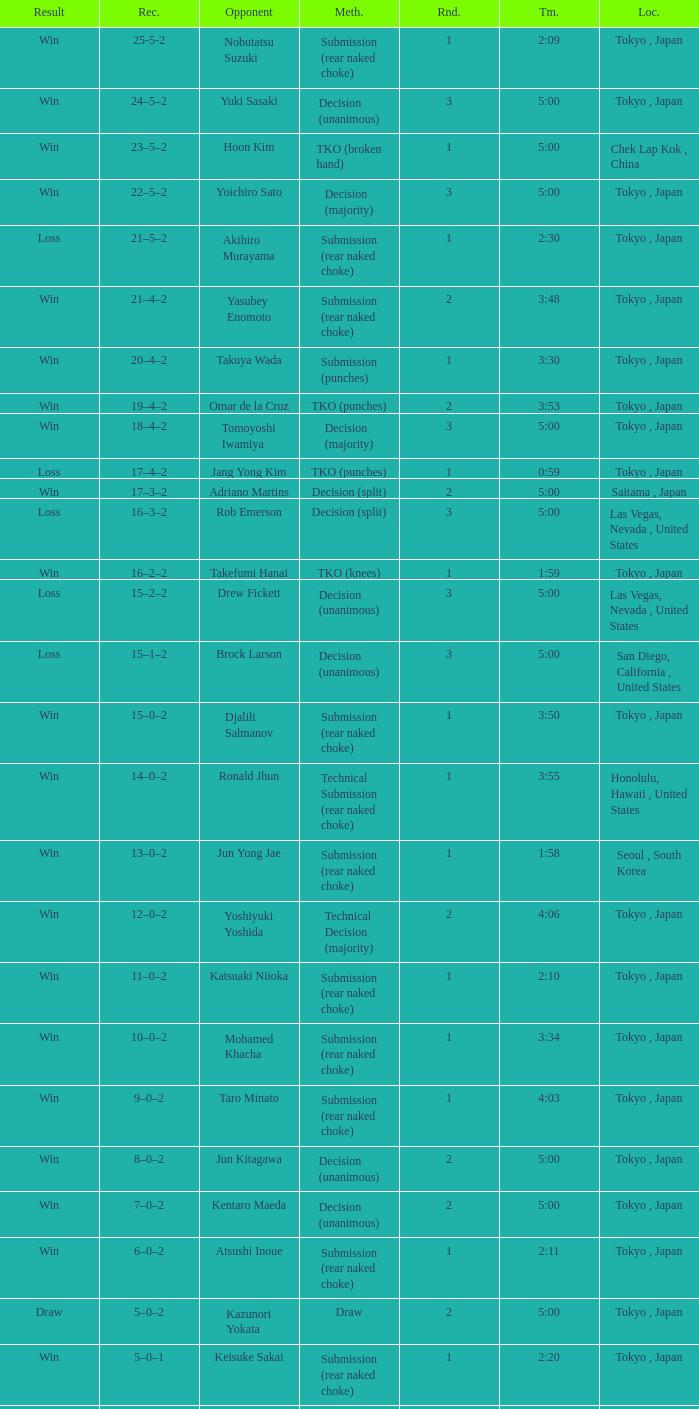What method had Adriano Martins as an opponent and a time of 5:00? Decision (split). Can you parse all the data within this table? {'header': ['Result', 'Rec.', 'Opponent', 'Meth.', 'Rnd.', 'Tm.', 'Loc.'], 'rows': [['Win', '25-5-2', 'Nobutatsu Suzuki', 'Submission (rear naked choke)', '1', '2:09', 'Tokyo , Japan'], ['Win', '24–5–2', 'Yuki Sasaki', 'Decision (unanimous)', '3', '5:00', 'Tokyo , Japan'], ['Win', '23–5–2', 'Hoon Kim', 'TKO (broken hand)', '1', '5:00', 'Chek Lap Kok , China'], ['Win', '22–5–2', 'Yoichiro Sato', 'Decision (majority)', '3', '5:00', 'Tokyo , Japan'], ['Loss', '21–5–2', 'Akihiro Murayama', 'Submission (rear naked choke)', '1', '2:30', 'Tokyo , Japan'], ['Win', '21–4–2', 'Yasubey Enomoto', 'Submission (rear naked choke)', '2', '3:48', 'Tokyo , Japan'], ['Win', '20–4–2', 'Takuya Wada', 'Submission (punches)', '1', '3:30', 'Tokyo , Japan'], ['Win', '19–4–2', 'Omar de la Cruz', 'TKO (punches)', '2', '3:53', 'Tokyo , Japan'], ['Win', '18–4–2', 'Tomoyoshi Iwamiya', 'Decision (majority)', '3', '5:00', 'Tokyo , Japan'], ['Loss', '17–4–2', 'Jang Yong Kim', 'TKO (punches)', '1', '0:59', 'Tokyo , Japan'], ['Win', '17–3–2', 'Adriano Martins', 'Decision (split)', '2', '5:00', 'Saitama , Japan'], ['Loss', '16–3–2', 'Rob Emerson', 'Decision (split)', '3', '5:00', 'Las Vegas, Nevada , United States'], ['Win', '16–2–2', 'Takefumi Hanai', 'TKO (knees)', '1', '1:59', 'Tokyo , Japan'], ['Loss', '15–2–2', 'Drew Fickett', 'Decision (unanimous)', '3', '5:00', 'Las Vegas, Nevada , United States'], ['Loss', '15–1–2', 'Brock Larson', 'Decision (unanimous)', '3', '5:00', 'San Diego, California , United States'], ['Win', '15–0–2', 'Djalili Salmanov', 'Submission (rear naked choke)', '1', '3:50', 'Tokyo , Japan'], ['Win', '14–0–2', 'Ronald Jhun', 'Technical Submission (rear naked choke)', '1', '3:55', 'Honolulu, Hawaii , United States'], ['Win', '13–0–2', 'Jun Yong Jae', 'Submission (rear naked choke)', '1', '1:58', 'Seoul , South Korea'], ['Win', '12–0–2', 'Yoshiyuki Yoshida', 'Technical Decision (majority)', '2', '4:06', 'Tokyo , Japan'], ['Win', '11–0–2', 'Katsuaki Niioka', 'Submission (rear naked choke)', '1', '2:10', 'Tokyo , Japan'], ['Win', '10–0–2', 'Mohamed Khacha', 'Submission (rear naked choke)', '1', '3:34', 'Tokyo , Japan'], ['Win', '9–0–2', 'Taro Minato', 'Submission (rear naked choke)', '1', '4:03', 'Tokyo , Japan'], ['Win', '8–0–2', 'Jun Kitagawa', 'Decision (unanimous)', '2', '5:00', 'Tokyo , Japan'], ['Win', '7–0–2', 'Kentaro Maeda', 'Decision (unanimous)', '2', '5:00', 'Tokyo , Japan'], ['Win', '6–0–2', 'Atsushi Inoue', 'Submission (rear naked choke)', '1', '2:11', 'Tokyo , Japan'], ['Draw', '5–0–2', 'Kazunori Yokata', 'Draw', '2', '5:00', 'Tokyo , Japan'], ['Win', '5–0–1', 'Keisuke Sakai', 'Submission (rear naked choke)', '1', '2:20', 'Tokyo , Japan'], ['Win', '4–0–1', 'Ichiro Kanai', 'Decision (unanimous)', '2', '5:00', 'Tokyo , Japan'], ['Win', '3–0–1', 'Daisuke Nakamura', 'Decision (unanimous)', '2', '5:00', 'Tokyo , Japan'], ['Draw', '2–0–1', 'Ichiro Kanai', 'Draw', '2', '5:00', 'Tokyo , Japan'], ['Win', '2–0', 'Kenta Omori', 'Submission (triangle choke)', '1', '7:44', 'Tokyo , Japan'], ['Win', '1–0', 'Tomohito Tanizaki', 'TKO (punches)', '1', '0:33', 'Tokyo , Japan']]} 